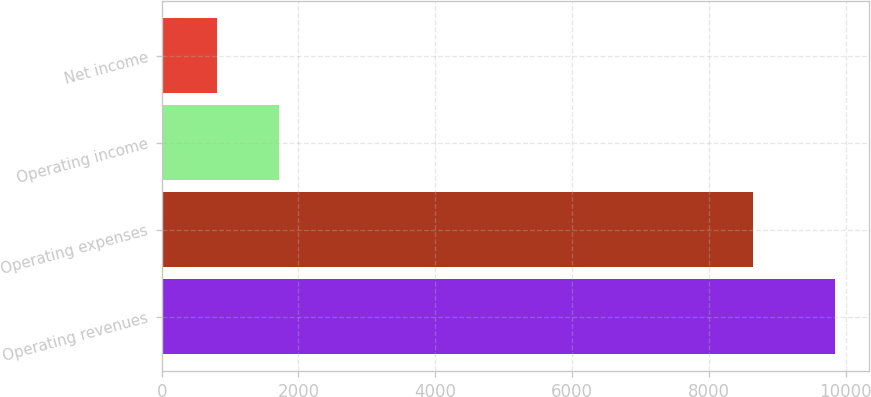<chart> <loc_0><loc_0><loc_500><loc_500><bar_chart><fcel>Operating revenues<fcel>Operating expenses<fcel>Operating income<fcel>Net income<nl><fcel>9842<fcel>8641<fcel>1711.4<fcel>808<nl></chart> 